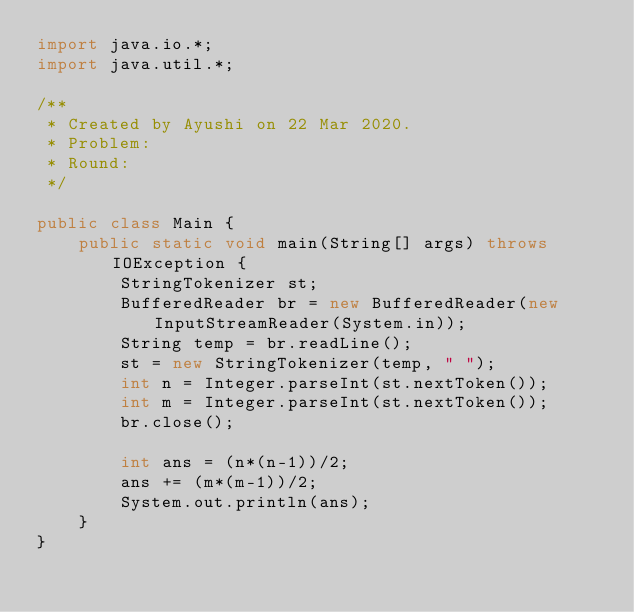<code> <loc_0><loc_0><loc_500><loc_500><_Java_>import java.io.*;
import java.util.*;

/**
 * Created by Ayushi on 22 Mar 2020.
 * Problem:
 * Round:
 */

public class Main {
    public static void main(String[] args) throws IOException {
        StringTokenizer st;
        BufferedReader br = new BufferedReader(new InputStreamReader(System.in));
        String temp = br.readLine();
        st = new StringTokenizer(temp, " ");
        int n = Integer.parseInt(st.nextToken());
        int m = Integer.parseInt(st.nextToken());
        br.close();

        int ans = (n*(n-1))/2;
        ans += (m*(m-1))/2;
        System.out.println(ans);
    }
}
</code> 